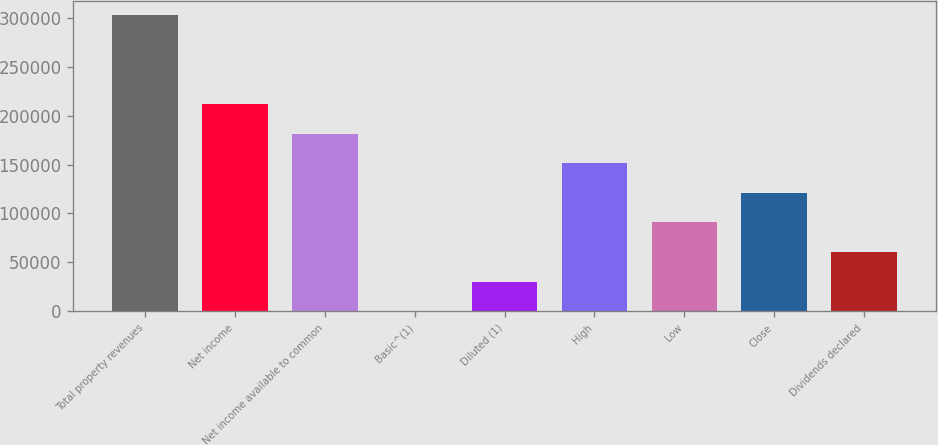<chart> <loc_0><loc_0><loc_500><loc_500><bar_chart><fcel>Total property revenues<fcel>Net income<fcel>Net income available to common<fcel>Basic^(1)<fcel>Diluted (1)<fcel>High<fcel>Low<fcel>Close<fcel>Dividends declared<nl><fcel>302522<fcel>211766<fcel>181513<fcel>0.65<fcel>30252.8<fcel>151261<fcel>90757<fcel>121009<fcel>60504.9<nl></chart> 